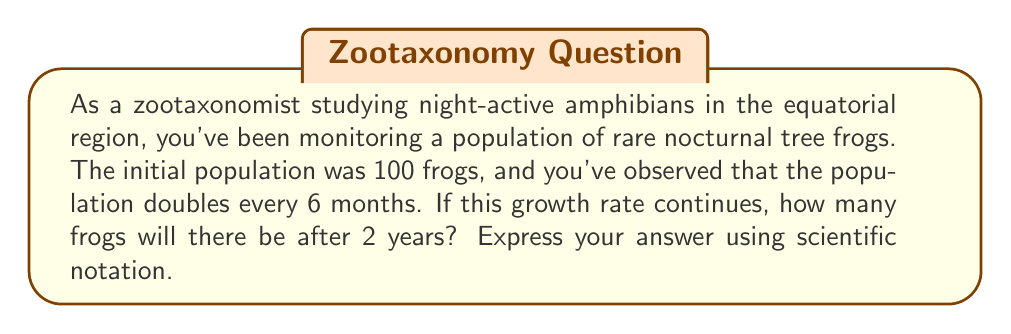Give your solution to this math problem. Let's approach this step-by-step:

1) We're dealing with exponential growth. The general formula for exponential growth is:

   $$A = P(1 + r)^t$$

   Where:
   $A$ = final amount
   $P$ = initial principal balance
   $r$ = growth rate (in decimal form)
   $t$ = time periods elapsed

2) In this case:
   $P = 100$ (initial population)
   $r = 1$ (100% growth rate, as the population doubles)
   $t = 4$ (2 years = 4 six-month periods)

3) However, we need to adjust our formula slightly because the doubling occurs every 6 months, not annually. Our formula becomes:

   $$A = P(2)^t$$

4) Now we can plug in our values:

   $$A = 100(2)^4$$

5) Let's solve this:
   $$A = 100 * 16 = 1600$$

6) To express this in scientific notation:

   $$A = 1.6 * 10^3$$

Thus, after 2 years, there will be 1600 frogs, or $1.6 * 10^3$ in scientific notation.
Answer: $1.6 * 10^3$ 